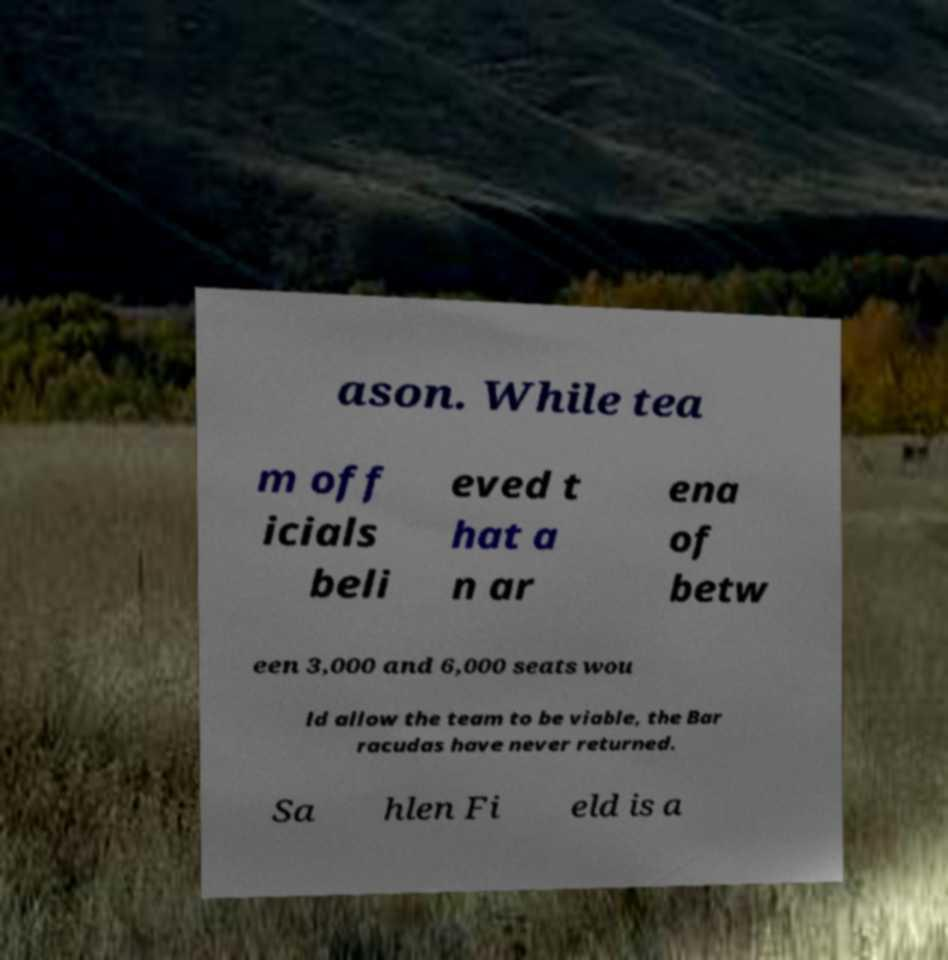For documentation purposes, I need the text within this image transcribed. Could you provide that? ason. While tea m off icials beli eved t hat a n ar ena of betw een 3,000 and 6,000 seats wou ld allow the team to be viable, the Bar racudas have never returned. Sa hlen Fi eld is a 